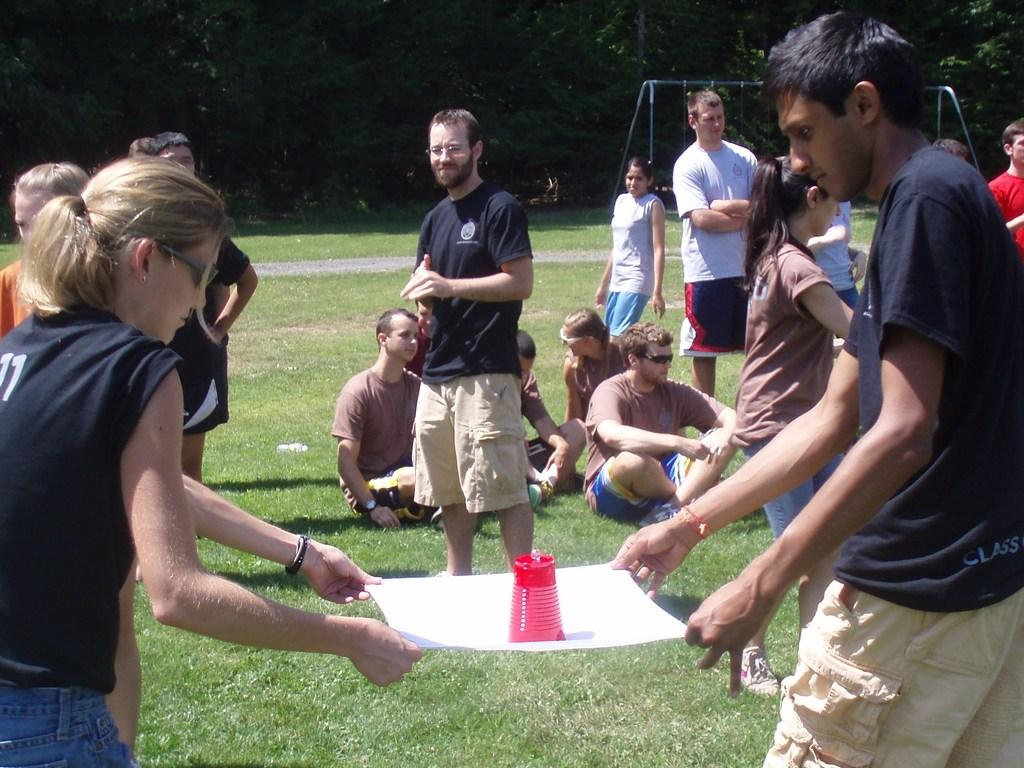What are the persons on the right side of the image holding? The persons on the right side of the image are holding a paper and a glass. What are the persons on the left side of the image holding? The persons on the left side of the image are also holding a paper and a glass. Can you describe the background of the image? The background of the image includes grass, swings, a road, and trees. Are there any other persons visible in the image besides those holding the paper and glass? Yes, there are persons visible in the background of the image. How many baby jellyfish can be seen swimming in the glass held by the persons in the image? There are no jellyfish, baby or otherwise, visible in the image. The persons are holding a glass, but it is not filled with jellyfish. 